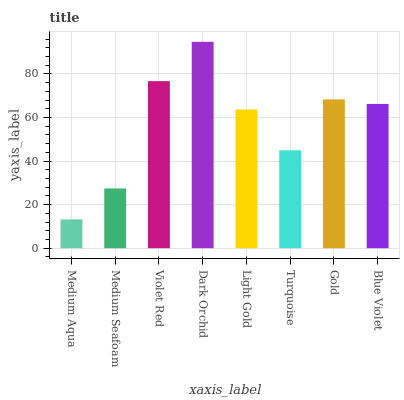Is Medium Aqua the minimum?
Answer yes or no. Yes. Is Dark Orchid the maximum?
Answer yes or no. Yes. Is Medium Seafoam the minimum?
Answer yes or no. No. Is Medium Seafoam the maximum?
Answer yes or no. No. Is Medium Seafoam greater than Medium Aqua?
Answer yes or no. Yes. Is Medium Aqua less than Medium Seafoam?
Answer yes or no. Yes. Is Medium Aqua greater than Medium Seafoam?
Answer yes or no. No. Is Medium Seafoam less than Medium Aqua?
Answer yes or no. No. Is Blue Violet the high median?
Answer yes or no. Yes. Is Light Gold the low median?
Answer yes or no. Yes. Is Medium Aqua the high median?
Answer yes or no. No. Is Turquoise the low median?
Answer yes or no. No. 